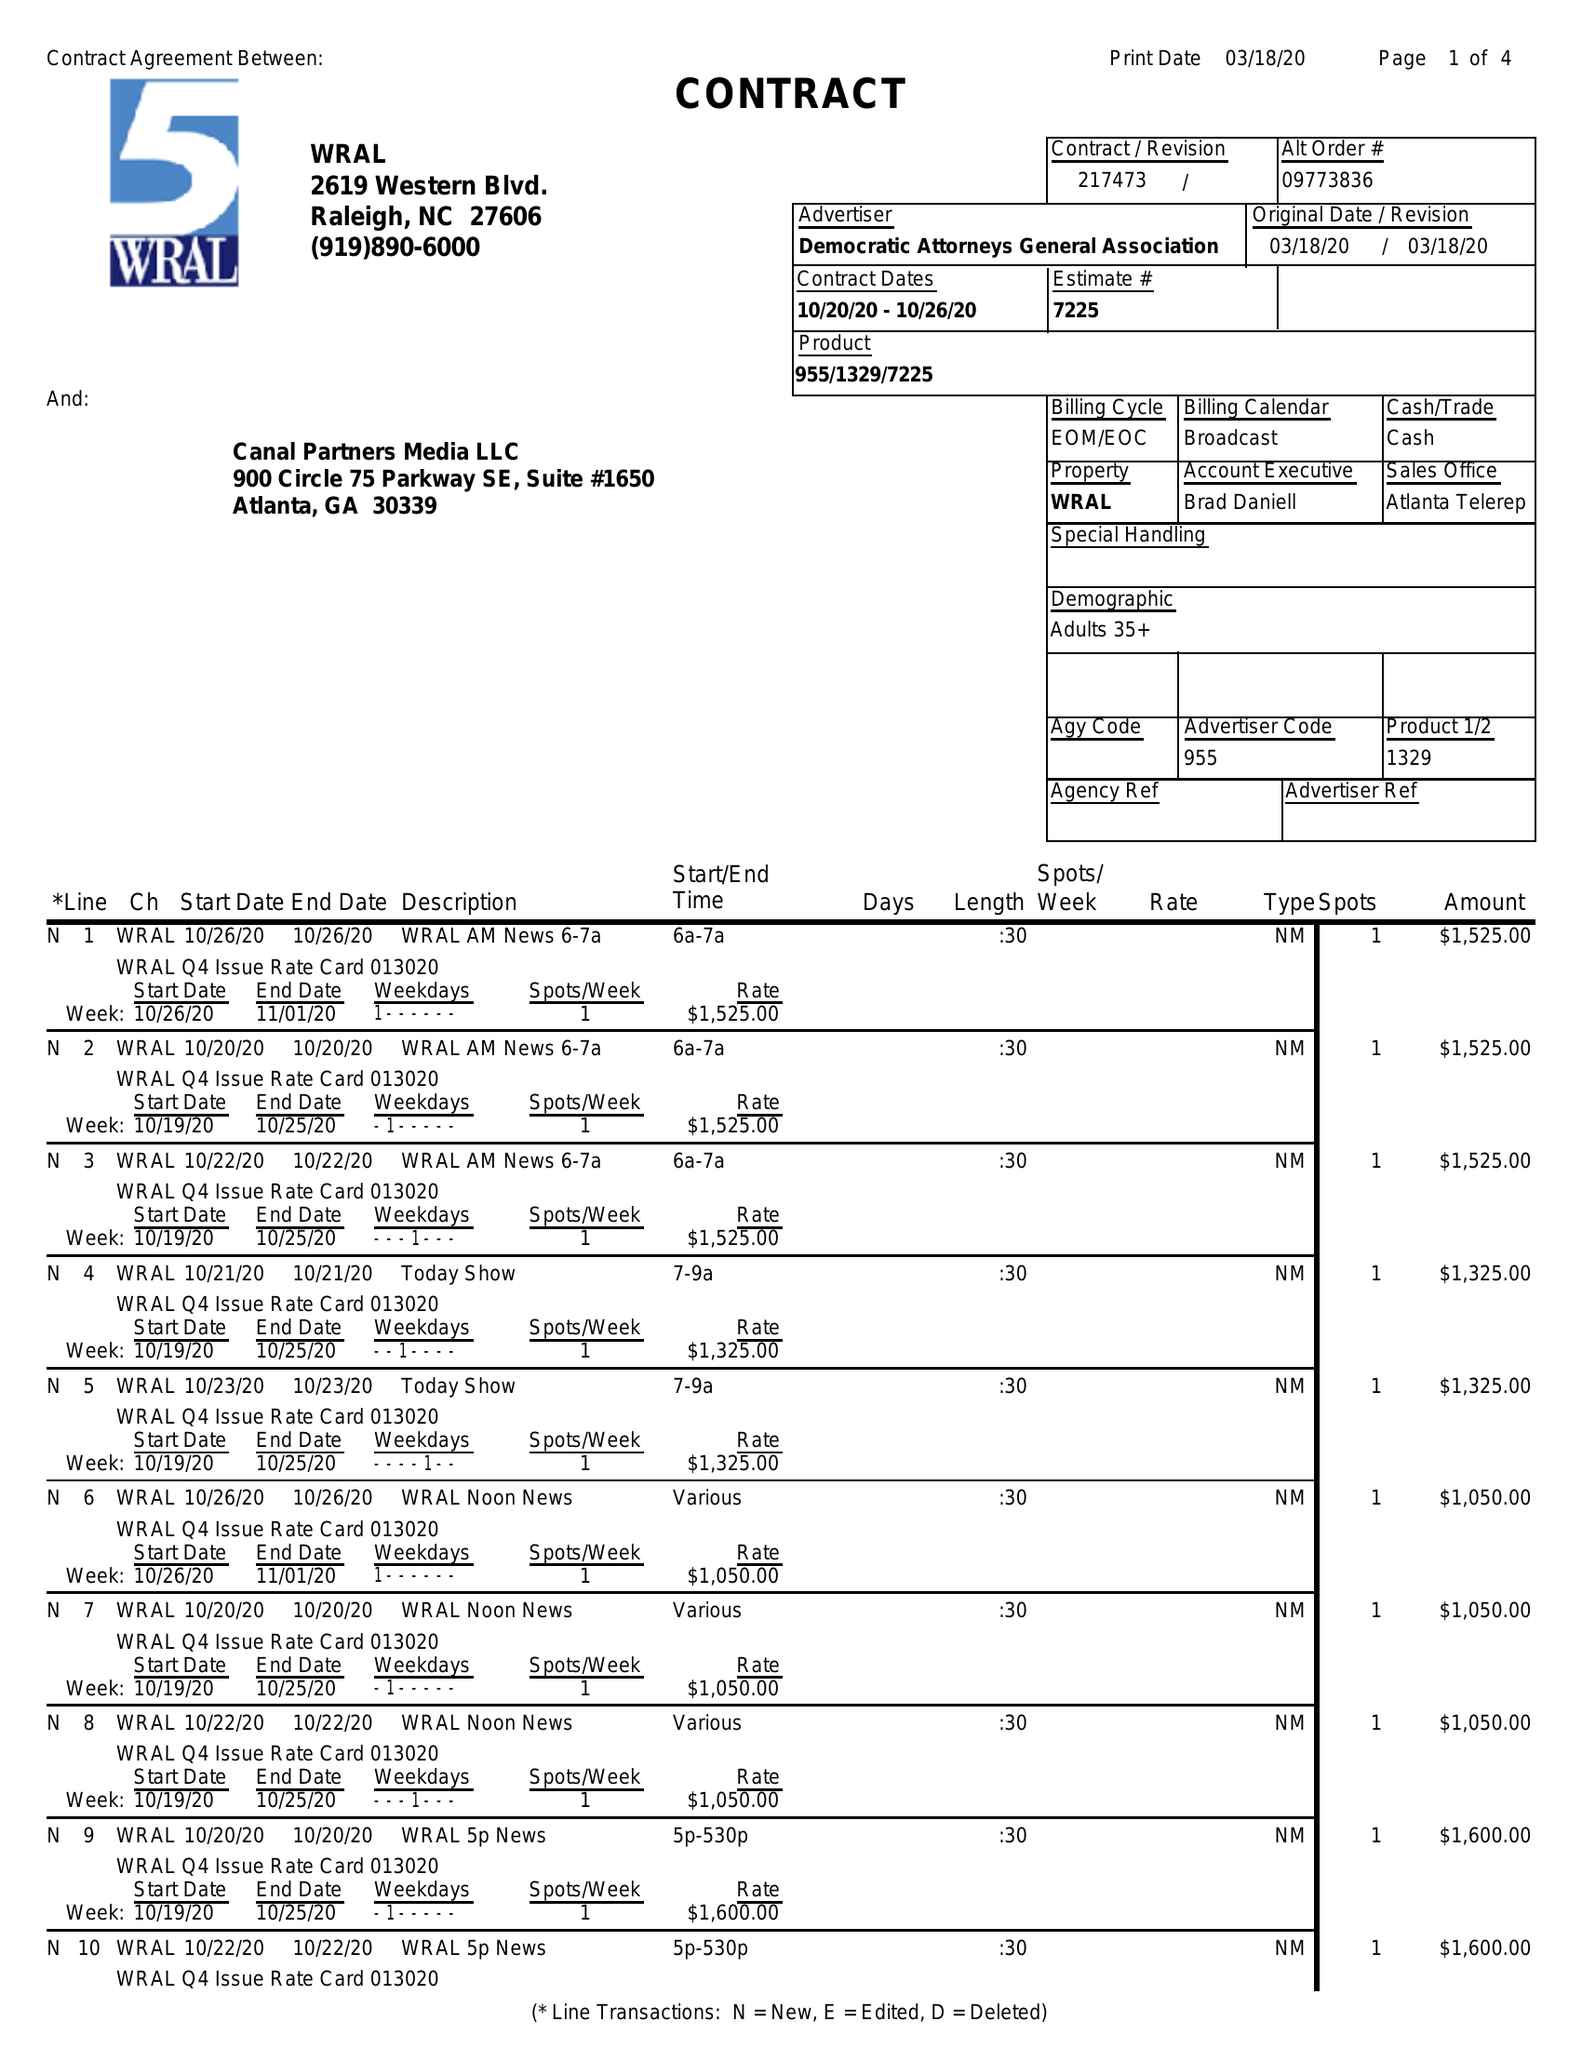What is the value for the flight_from?
Answer the question using a single word or phrase. 10/20/20 